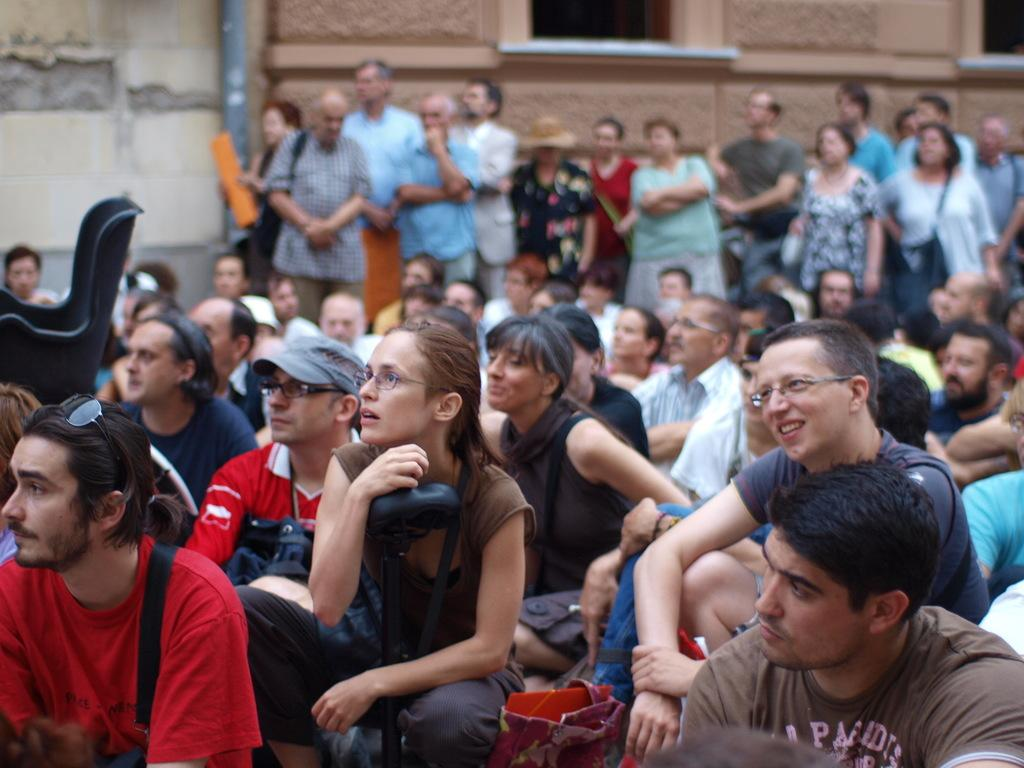What are the people in the image doing? Some people are sitting and some are standing in the center of the image. Can you describe the background of the image? There are buildings in the background of the image. How many yaks can be seen in the image? There are no yaks present in the image. What type of steam is visible coming from the buildings in the image? There is no steam visible coming from the buildings in the image. 